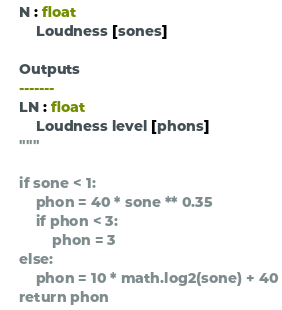Convert code to text. <code><loc_0><loc_0><loc_500><loc_500><_Python_>    N : float
        Loudness [sones]

    Outputs
    -------
    LN : float
        Loudness level [phons]
    """

    if sone < 1:
        phon = 40 * sone ** 0.35
        if phon < 3:
            phon = 3
    else:
        phon = 10 * math.log2(sone) + 40
    return phon
</code> 